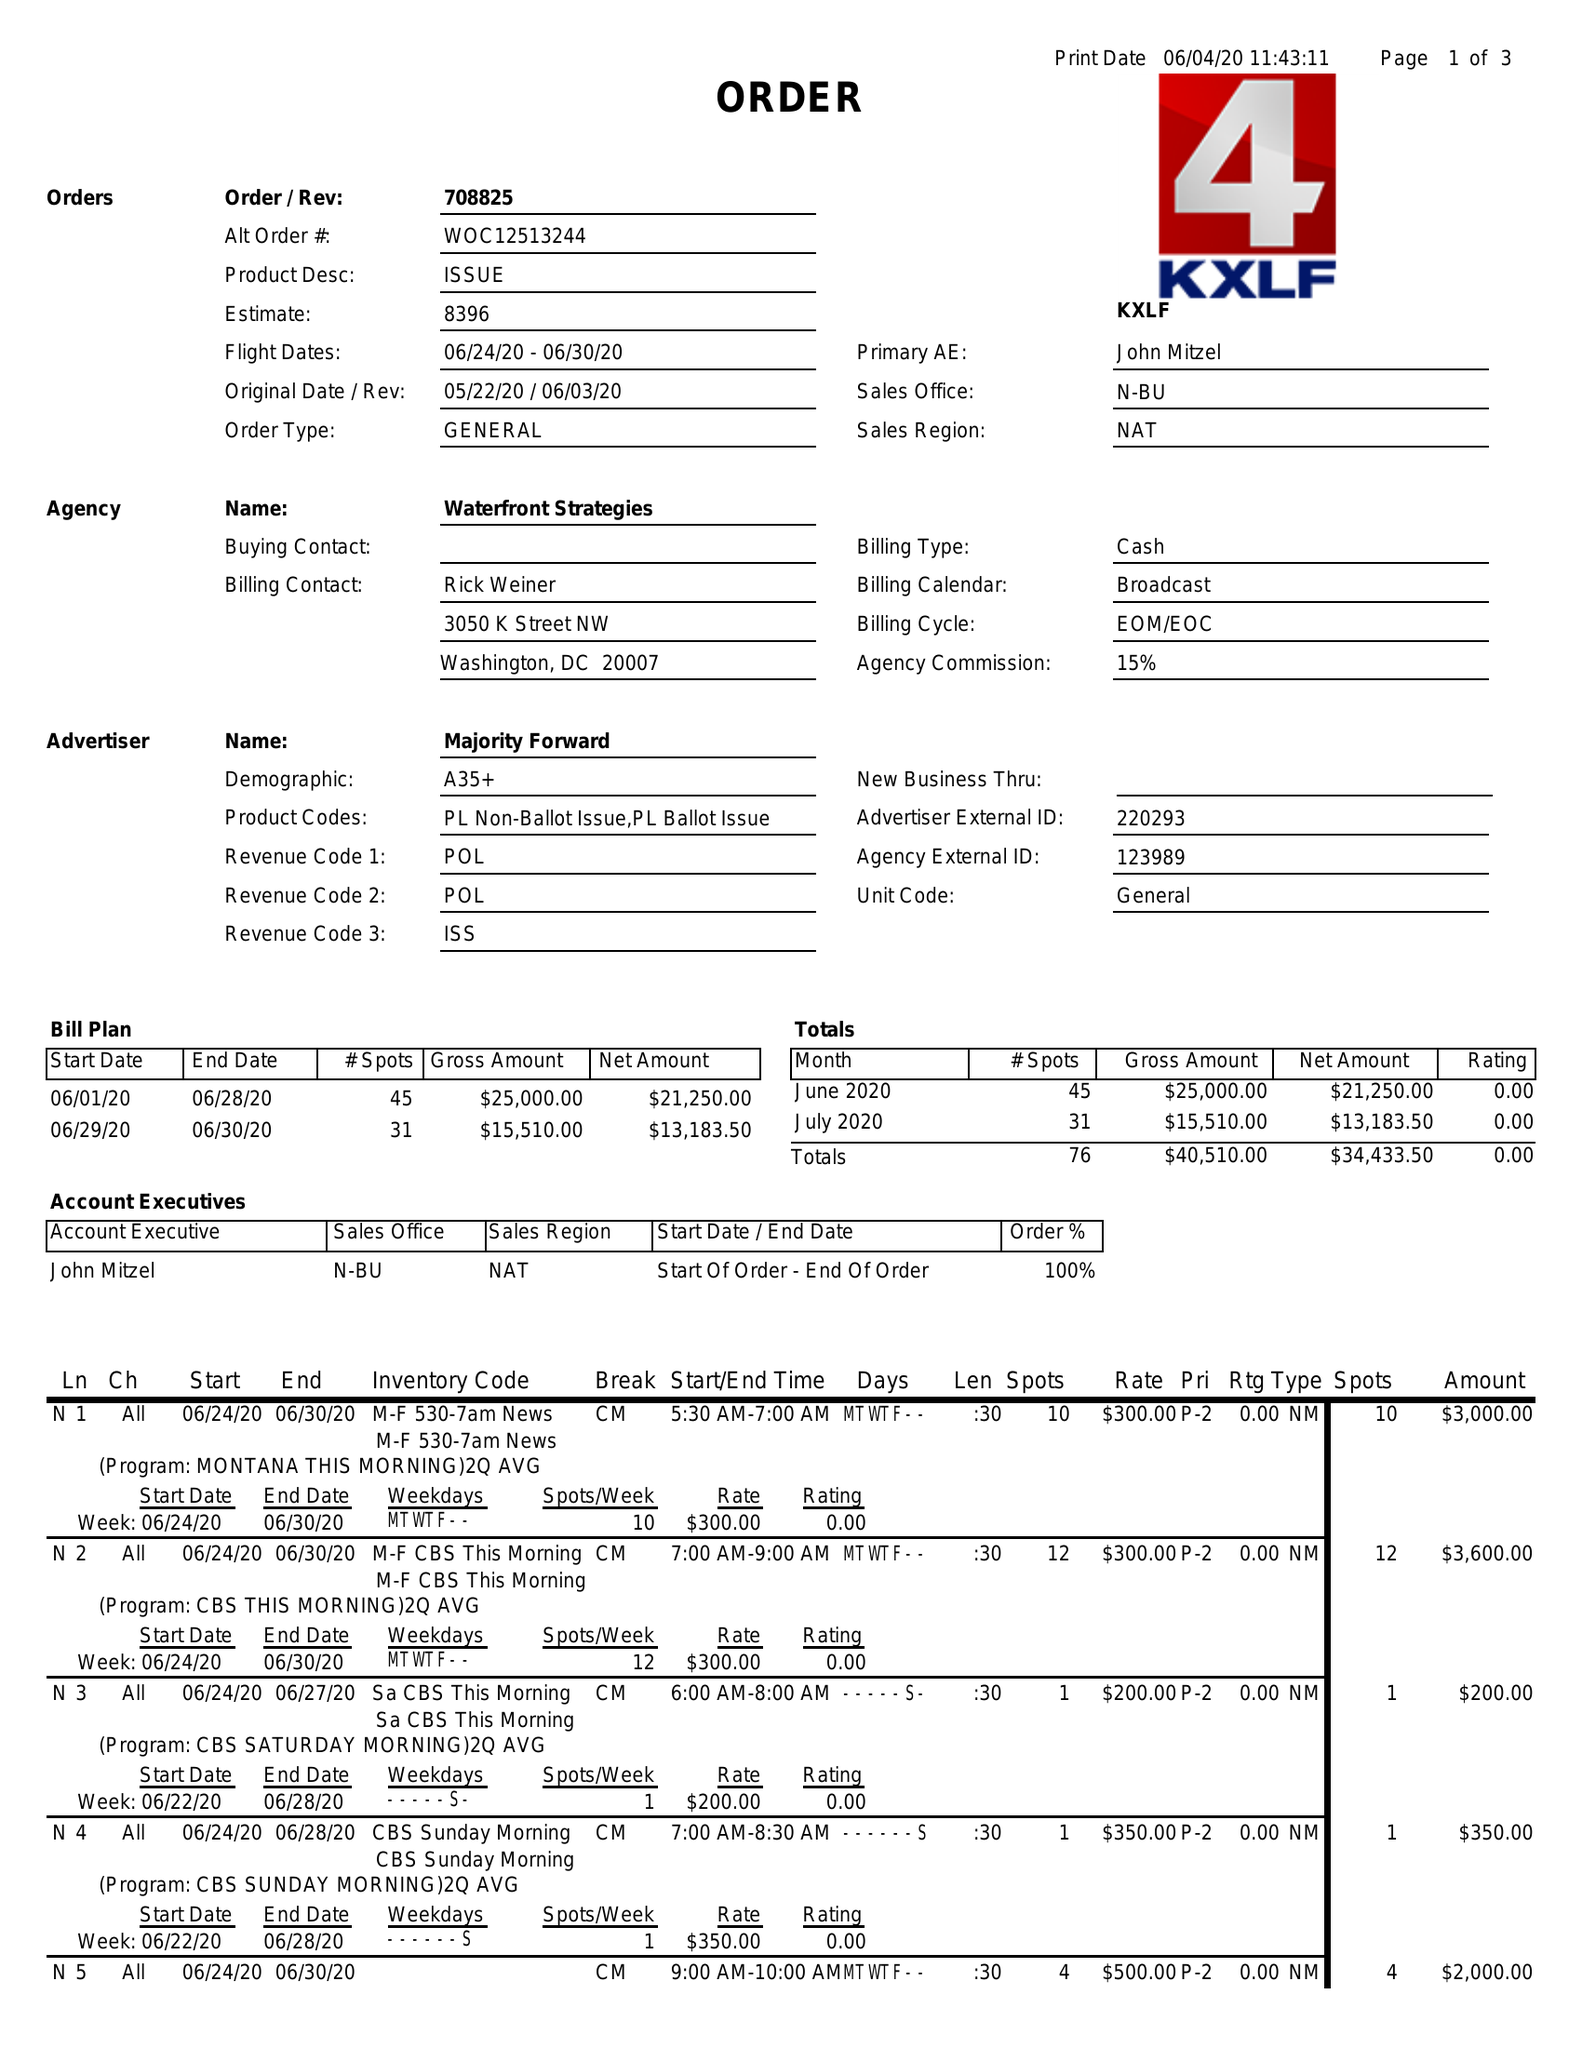What is the value for the gross_amount?
Answer the question using a single word or phrase. 40510.00 